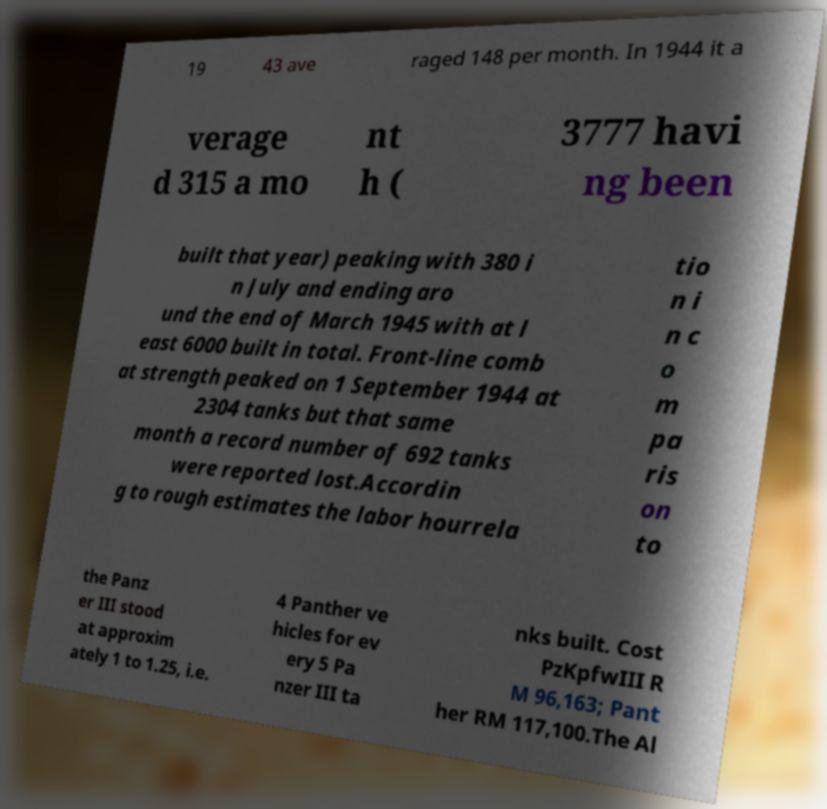Can you read and provide the text displayed in the image?This photo seems to have some interesting text. Can you extract and type it out for me? 19 43 ave raged 148 per month. In 1944 it a verage d 315 a mo nt h ( 3777 havi ng been built that year) peaking with 380 i n July and ending aro und the end of March 1945 with at l east 6000 built in total. Front-line comb at strength peaked on 1 September 1944 at 2304 tanks but that same month a record number of 692 tanks were reported lost.Accordin g to rough estimates the labor hourrela tio n i n c o m pa ris on to the Panz er III stood at approxim ately 1 to 1.25, i.e. 4 Panther ve hicles for ev ery 5 Pa nzer III ta nks built. Cost PzKpfwIII R M 96,163; Pant her RM 117,100.The Al 